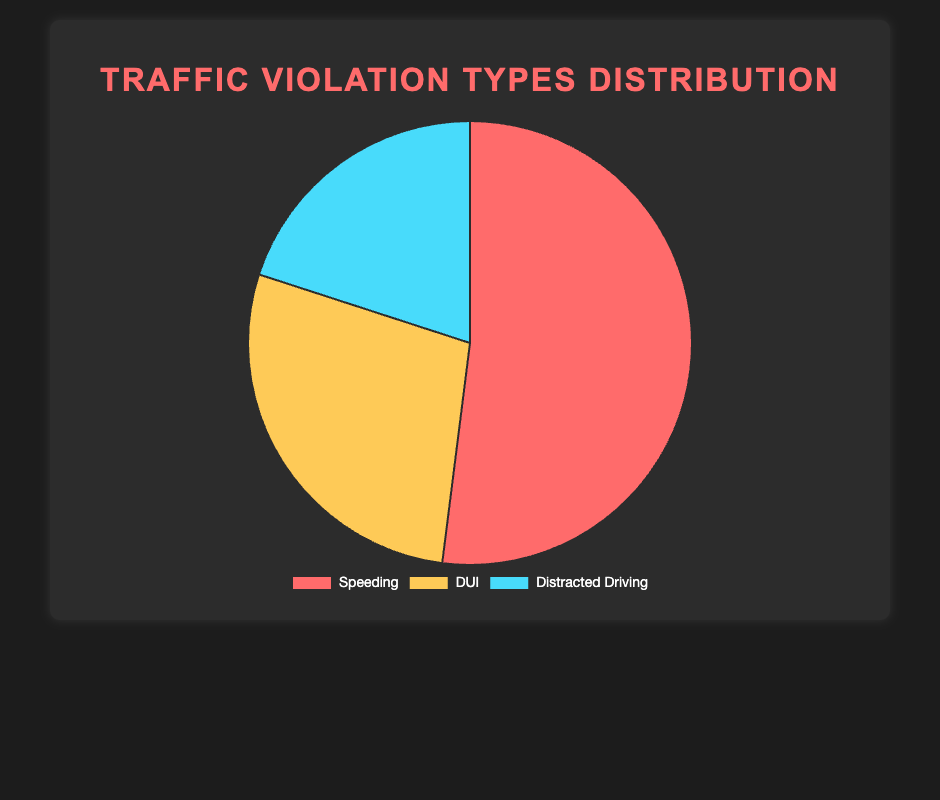What percentage of traffic violations is due to DUI? The pie chart shows the distribution of traffic violations with each segment's percentage. The section for DUI is labeled with 28%.
Answer: 28% Based on the pie chart, how many more incidents of speeding are there compared to distracted driving? Speeding incidents are 2413, and distracted driving incidents are 913. Subtracting distracted driving from speeding: 2413 - 913 = 1500 incidents.
Answer: 1500 If the number of DUI incidents were to double, what would be their new percentage in the total traffic violations? Doubling the DUI incidents: 1307 * 2 = 2614. Adding the new DUI incidents to the total incidents: 2413 (Speeding) + 2614 (New DUI) + 913 (Distracted Driving) = 5940. The new percentage for DUI: (2614/5940) * 100 ≈ 44%.
Answer: 44% What is the combined percentage of speeding and distracted driving violations? The pie chart indicates 52% for speeding and 20% for distracted driving. Adding these percentages: 52% + 20% = 72%.
Answer: 72% Which traffic violation type is represented by the blue section? The blue section in the pie chart corresponds to ‘Distracted Driving’ as represented in the visual data.
Answer: Distracted Driving How does the number of DUI incidents compare to the total of other types combined? The pie chart gives the number of DUI incidents as 1307 and the other types combined (Speeding and Distracted Driving) as 2413 + 913 = 3326. From this, DUI incidents are fewer by 3326 - 1307 = 2019 incidents.
Answer: 2019 fewer What is the total number of traffic violations accounted for in the chart? Adding up all the incidents from each traffic violation type: 2413 (Speeding) + 1307 (DUI) + 913 (Distracted Driving) = 4633.
Answer: 4633 If distracted driving incidents increased by 50%, what would be the new percentage of distracted driving violations? Increasing the distracted driving incidents by 50%: 913 + (0.5 * 913) = 1370. New total incidents: 2413 (Speeding) + 1307 (DUI) + 1370 (New Distracted Driving) = 5090. The new percentage: (1370/5090) * 100 ≈ 27%.
Answer: 27% What is the ratio of speeding to DUI incidents? The pie chart indicates 2413 speeding incidents and 1307 DUI incidents. The ratio of speeding to DUI incidents is 2413/1307, which simplifies to approximately 1.85.
Answer: 1.85:1 Evaluate if the number of speeding incidents is more than three times the DUI incidents. Tripling the DUI incidents: 1307 * 3 = 3921. Compare this to speeding incidents: 2413 < 3921, so speeding is not more than three times the DUI incidents.
Answer: No 